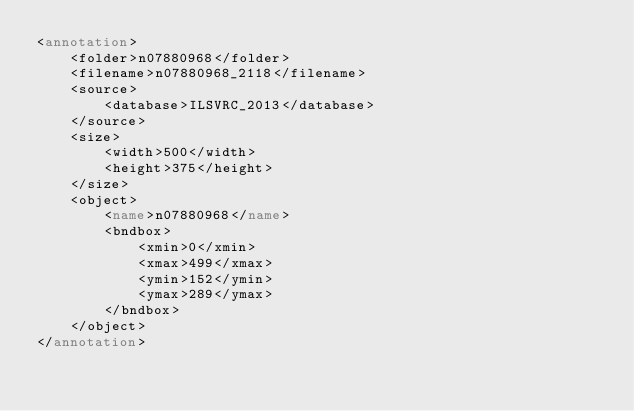<code> <loc_0><loc_0><loc_500><loc_500><_XML_><annotation>
	<folder>n07880968</folder>
	<filename>n07880968_2118</filename>
	<source>
		<database>ILSVRC_2013</database>
	</source>
	<size>
		<width>500</width>
		<height>375</height>
	</size>
	<object>
		<name>n07880968</name>
		<bndbox>
			<xmin>0</xmin>
			<xmax>499</xmax>
			<ymin>152</ymin>
			<ymax>289</ymax>
		</bndbox>
	</object>
</annotation>
</code> 